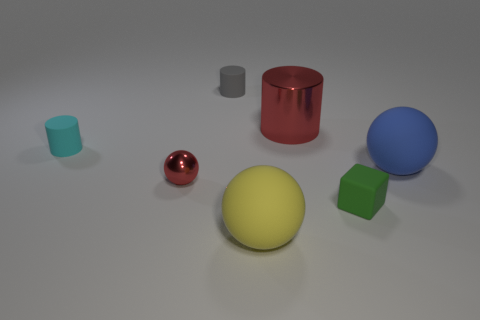Are there any big balls that have the same material as the small green thing?
Offer a terse response. Yes. What size is the other thing that is the same color as the large shiny object?
Keep it short and to the point. Small. How many balls are shiny things or tiny cyan objects?
Provide a short and direct response. 1. The green thing has what size?
Offer a terse response. Small. What number of tiny metal spheres are on the right side of the gray object?
Your answer should be very brief. 0. What size is the cylinder that is behind the big object that is behind the cyan thing?
Provide a succinct answer. Small. There is a red metal object behind the large blue rubber thing; does it have the same shape as the red shiny thing left of the large yellow object?
Keep it short and to the point. No. What is the shape of the red shiny thing that is behind the matte sphere behind the large yellow rubber sphere?
Make the answer very short. Cylinder. There is a thing that is both in front of the small red metallic thing and on the right side of the yellow object; what is its size?
Provide a succinct answer. Small. There is a big yellow matte object; is it the same shape as the red shiny thing that is left of the large shiny object?
Your answer should be compact. Yes. 